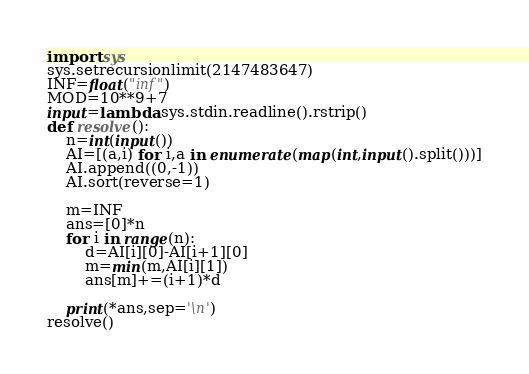<code> <loc_0><loc_0><loc_500><loc_500><_Python_>import sys
sys.setrecursionlimit(2147483647)
INF=float("inf")
MOD=10**9+7
input=lambda:sys.stdin.readline().rstrip()
def resolve():
    n=int(input())
    AI=[(a,i) for i,a in enumerate(map(int,input().split()))]
    AI.append((0,-1))
    AI.sort(reverse=1)

    m=INF
    ans=[0]*n
    for i in range(n):
        d=AI[i][0]-AI[i+1][0]
        m=min(m,AI[i][1])
        ans[m]+=(i+1)*d

    print(*ans,sep='\n')
resolve()</code> 